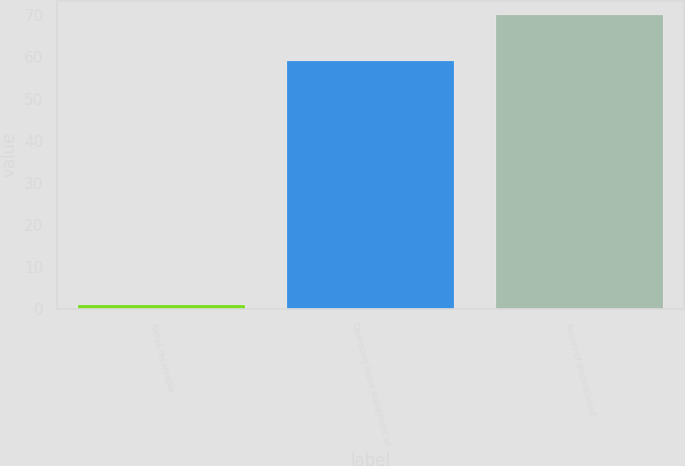Convert chart. <chart><loc_0><loc_0><loc_500><loc_500><bar_chart><fcel>Notes receivable<fcel>Operating lease equipment at<fcel>Assets of discontinued<nl><fcel>1<fcel>59<fcel>70<nl></chart> 